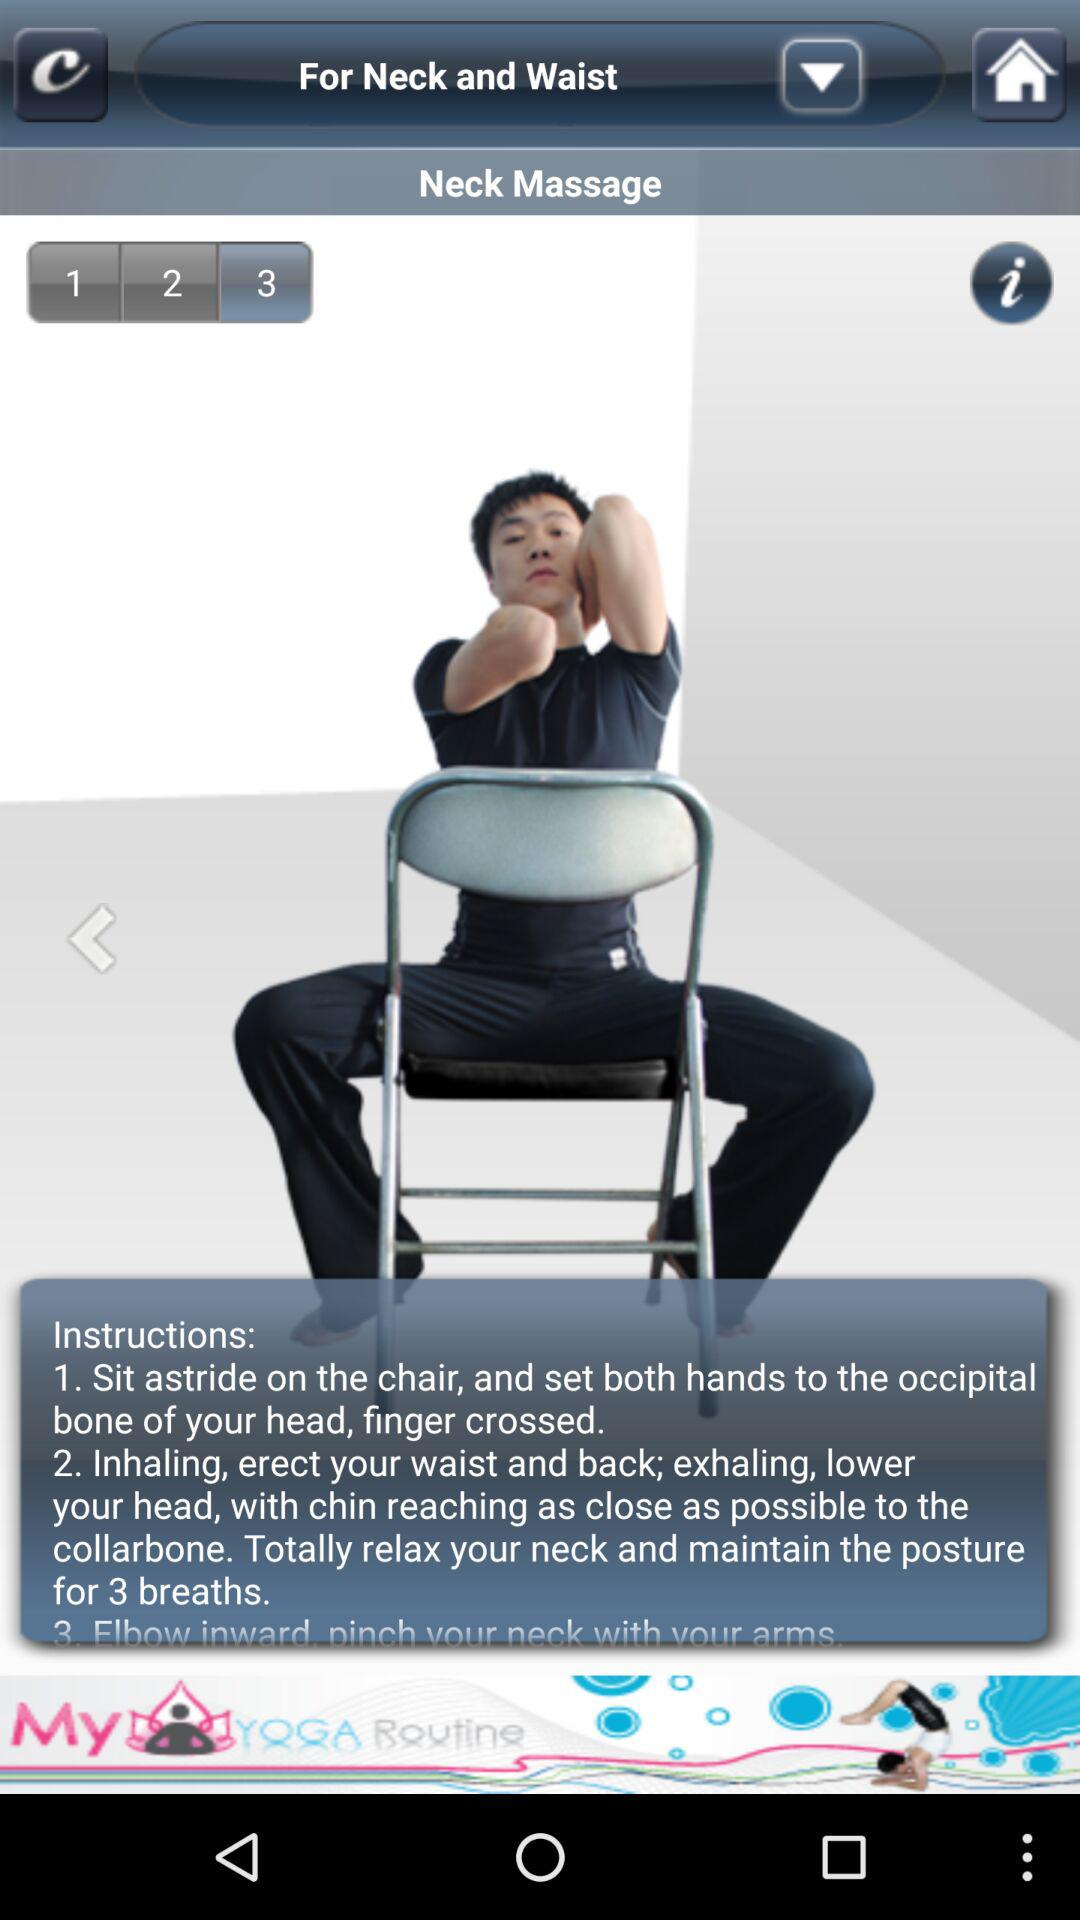Which button has been selected? The button that has been selected is 3. 